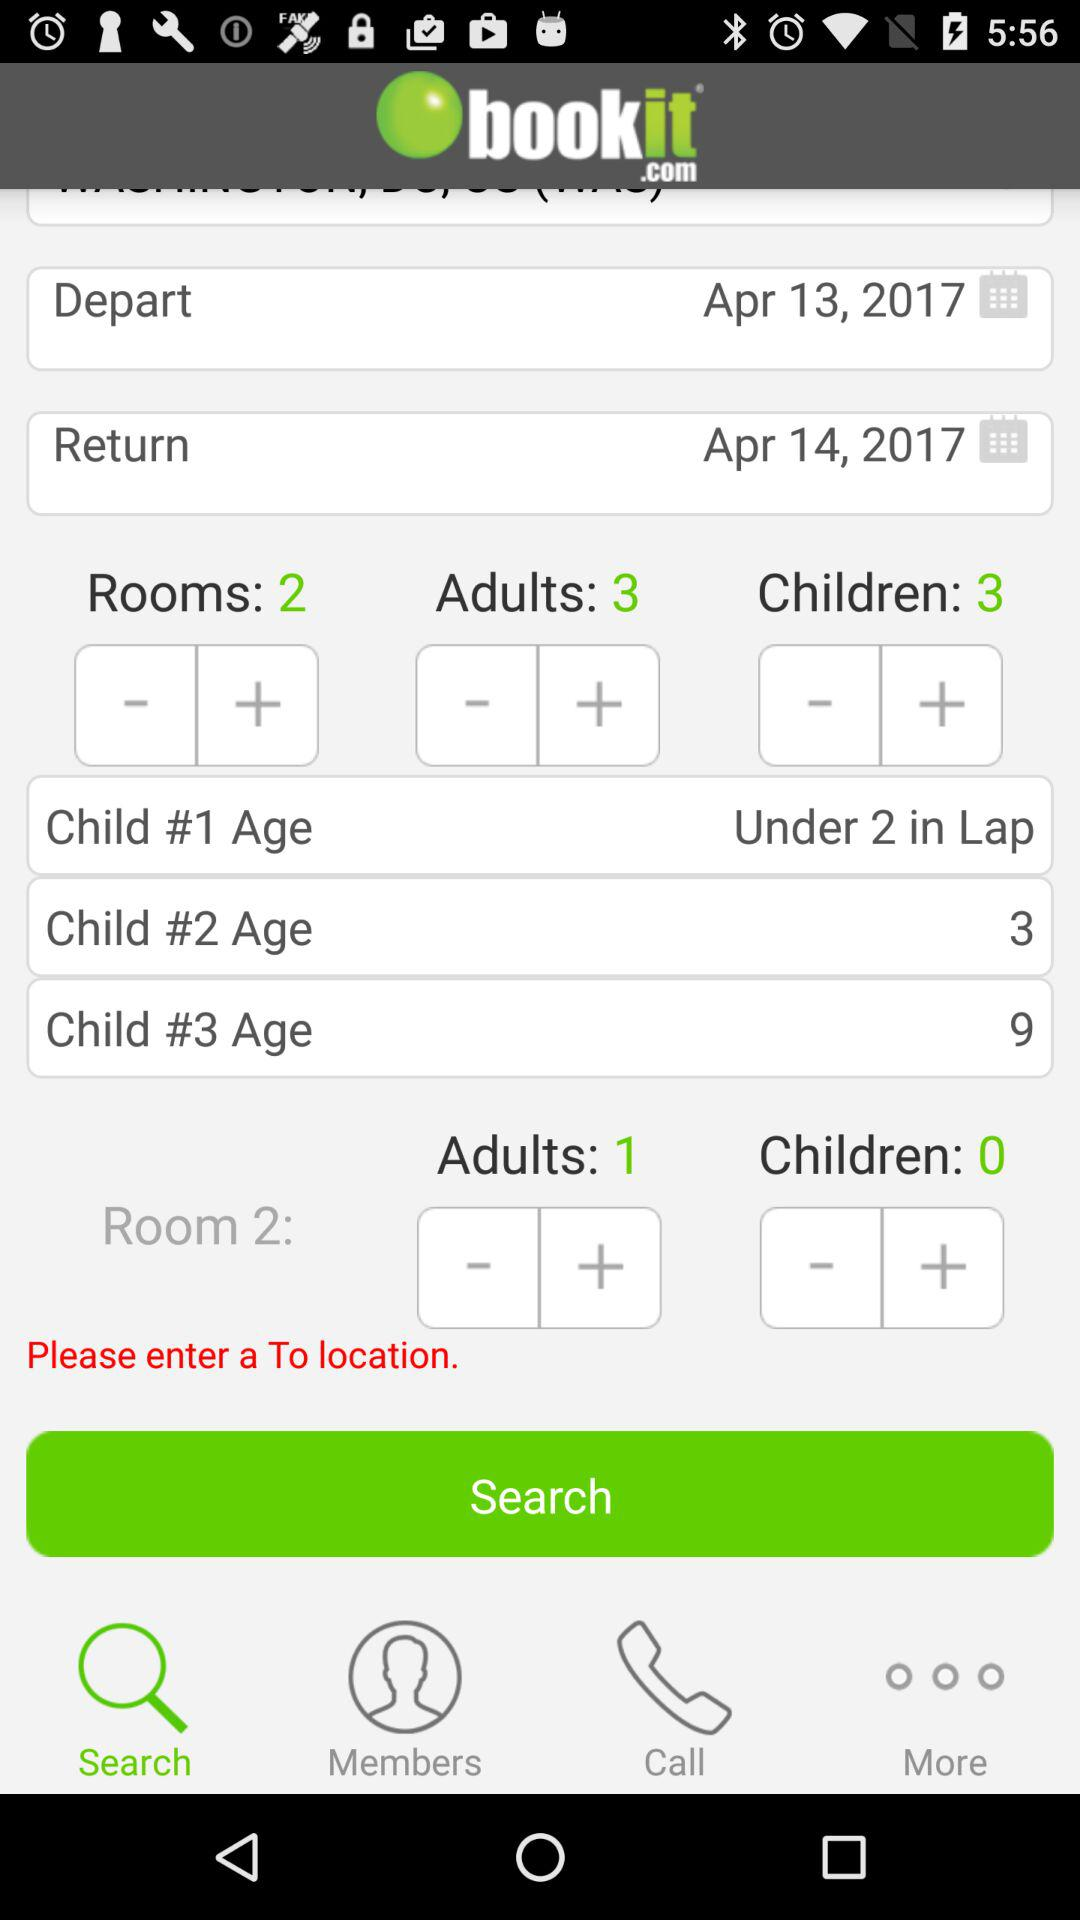How many rooms are there? There are 2 rooms. 